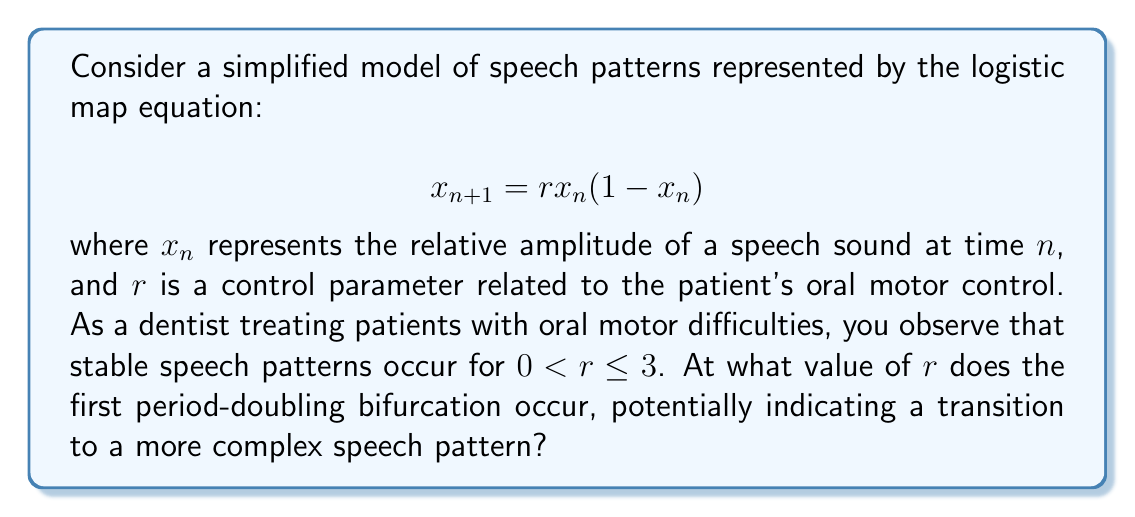Could you help me with this problem? To find the first period-doubling bifurcation point in the logistic map, we need to follow these steps:

1) In the stable regime ($0 < r \leq 3$), the system has a single fixed point. This fixed point $x^*$ satisfies:

   $$x^* = rx^*(1-x^*)$$

2) Solving this equation:
   
   $$x^* = 0$$ or $$x^* = 1 - \frac{1}{r}$$

   The non-zero fixed point is $x^* = 1 - \frac{1}{r}$ for $r > 1$.

3) To find when this fixed point becomes unstable (leading to period-doubling), we need to examine the derivative of the map at this fixed point:

   $$f'(x) = r(1-2x)$$

4) At the fixed point:

   $$f'(x^*) = r(1-2(1-\frac{1}{r})) = r(1-2+\frac{2}{r}) = 2-r$$

5) The fixed point becomes unstable when $|f'(x^*)| > 1$. In this case:

   $$|2-r| > 1$$

6) Solving this inequality:
   
   $$r > 3$$

Therefore, the first period-doubling bifurcation occurs at $r = 3$.

This bifurcation point represents a transition from a stable speech pattern to a more complex, oscillating pattern, which could indicate the onset of speech difficulties due to oral motor control issues.
Answer: $r = 3$ 